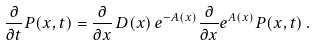<formula> <loc_0><loc_0><loc_500><loc_500>\frac { \partial } { \partial t } P ( x , t ) = \frac { \partial } { \partial x } \, D ( x ) \, e ^ { - A ( x ) } \frac { \partial } { \partial x } e ^ { A ( x ) } P ( x , t ) \, .</formula> 